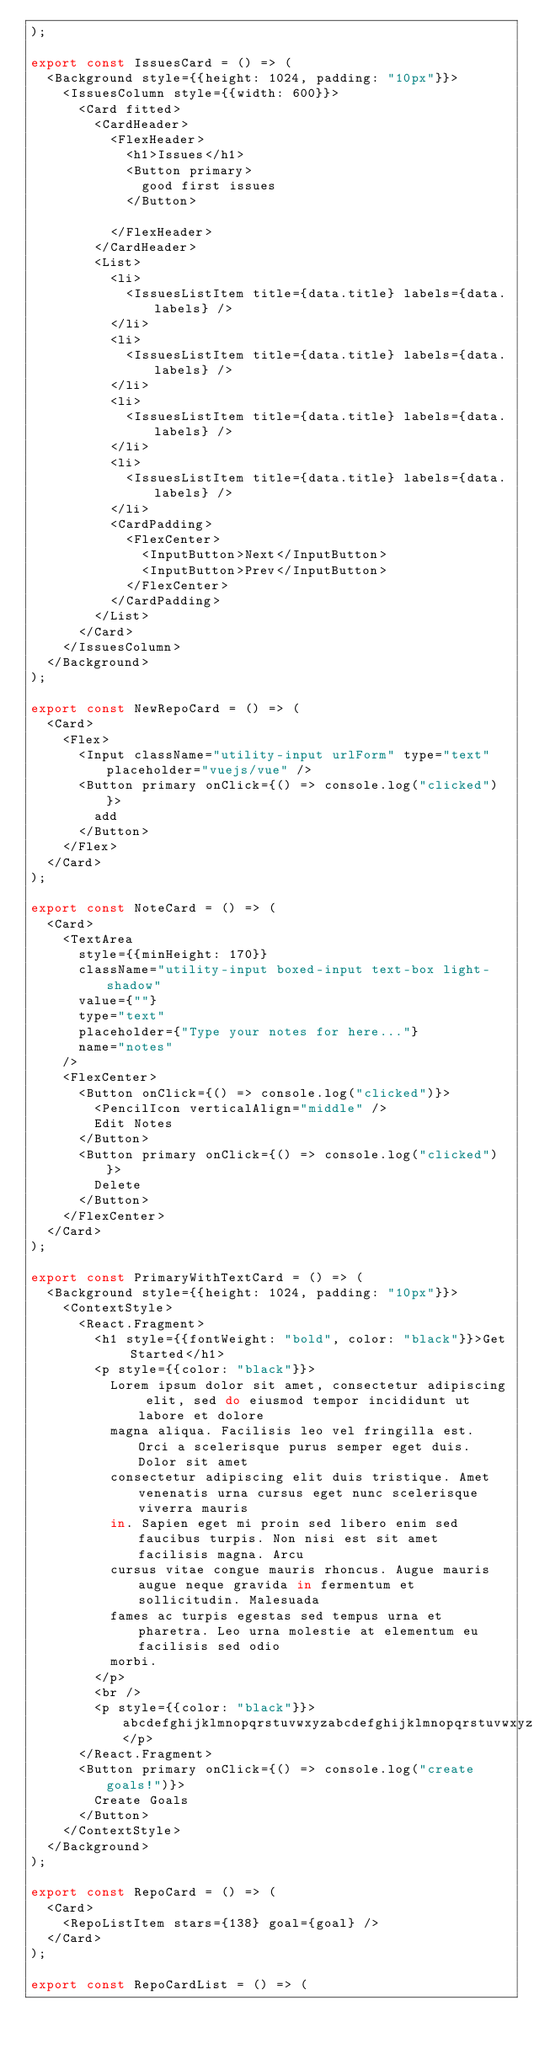Convert code to text. <code><loc_0><loc_0><loc_500><loc_500><_JavaScript_>);

export const IssuesCard = () => (
  <Background style={{height: 1024, padding: "10px"}}>
    <IssuesColumn style={{width: 600}}>
      <Card fitted>
        <CardHeader>
          <FlexHeader>
            <h1>Issues</h1>
            <Button primary>
              good first issues
            </Button>

          </FlexHeader>
        </CardHeader>
        <List>
          <li>
            <IssuesListItem title={data.title} labels={data.labels} />
          </li>
          <li>
            <IssuesListItem title={data.title} labels={data.labels} />
          </li>
          <li>
            <IssuesListItem title={data.title} labels={data.labels} />
          </li>
          <li>
            <IssuesListItem title={data.title} labels={data.labels} />
          </li>
          <CardPadding>
            <FlexCenter>
              <InputButton>Next</InputButton>
              <InputButton>Prev</InputButton>
            </FlexCenter>
          </CardPadding>
        </List>
      </Card>
    </IssuesColumn>
  </Background>
);

export const NewRepoCard = () => (
  <Card>
    <Flex>
      <Input className="utility-input urlForm" type="text" placeholder="vuejs/vue" />
      <Button primary onClick={() => console.log("clicked")}>
        add
      </Button>
    </Flex>
  </Card>
);

export const NoteCard = () => (
  <Card>
    <TextArea
      style={{minHeight: 170}}
      className="utility-input boxed-input text-box light-shadow"
      value={""}
      type="text"
      placeholder={"Type your notes for here..."}
      name="notes"
    />
    <FlexCenter>
      <Button onClick={() => console.log("clicked")}>
        <PencilIcon verticalAlign="middle" />
        Edit Notes
      </Button>
      <Button primary onClick={() => console.log("clicked")}>
        Delete
      </Button>
    </FlexCenter>
  </Card>
);

export const PrimaryWithTextCard = () => (
  <Background style={{height: 1024, padding: "10px"}}>
    <ContextStyle>
      <React.Fragment>
        <h1 style={{fontWeight: "bold", color: "black"}}>Get Started</h1>
        <p style={{color: "black"}}>
          Lorem ipsum dolor sit amet, consectetur adipiscing elit, sed do eiusmod tempor incididunt ut labore et dolore
          magna aliqua. Facilisis leo vel fringilla est. Orci a scelerisque purus semper eget duis. Dolor sit amet
          consectetur adipiscing elit duis tristique. Amet venenatis urna cursus eget nunc scelerisque viverra mauris
          in. Sapien eget mi proin sed libero enim sed faucibus turpis. Non nisi est sit amet facilisis magna. Arcu
          cursus vitae congue mauris rhoncus. Augue mauris augue neque gravida in fermentum et sollicitudin. Malesuada
          fames ac turpis egestas sed tempus urna et pharetra. Leo urna molestie at elementum eu facilisis sed odio
          morbi.
        </p>
        <br />
        <p style={{color: "black"}}>abcdefghijklmnopqrstuvwxyzabcdefghijklmnopqrstuvwxyzabcdefghijklmnopqrstuvwxyz</p>
      </React.Fragment>
      <Button primary onClick={() => console.log("create goals!")}>
        Create Goals
      </Button>
    </ContextStyle>
  </Background>
);

export const RepoCard = () => (
  <Card>
    <RepoListItem stars={138} goal={goal} />
  </Card>
);

export const RepoCardList = () => (</code> 